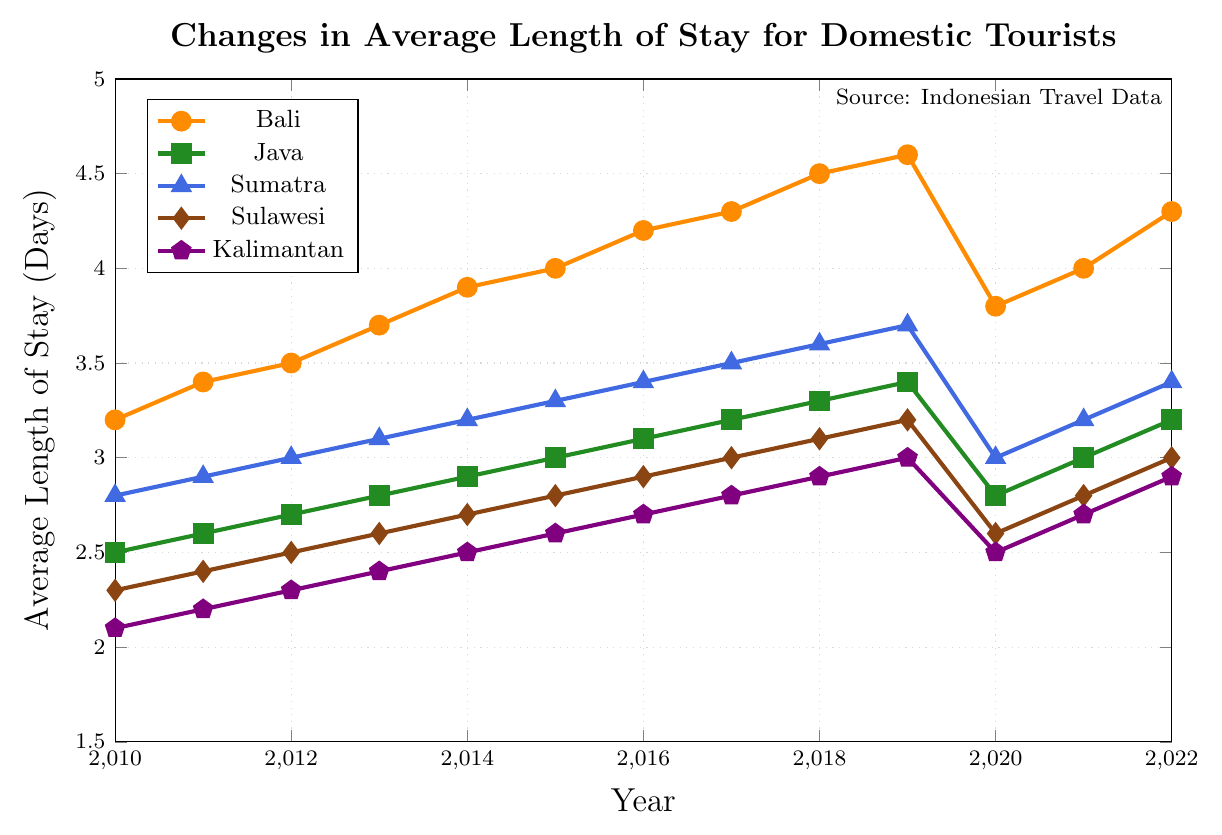What region had the longest average stay for domestic tourists in 2022? Observing the figure, the Bali line reaches the highest point in 2022, indicating the longest average stay for domestic tourists.
Answer: Bali How did the average length of stay in Bali change from 2019 to 2020? Comparing the points for Bali between 2019 and 2020, the average stay decreased from 4.6 to 3.8 days.
Answer: It decreased Which region experienced the biggest drop in the average length of stay in 2020 compared to 2019? Looking at the steepest drop between 2019 and 2020, all regions experienced a decline, but Bali had the most significant drop from 4.6 to 3.8.
Answer: Bali What is the trend of the average length of stay in Sulawesi from 2010 to 2022? Observing the Sulawesi line, it shows a general upward trend from 2.3 days in 2010 to 3.0 days in 2022, with a slight dip in 2020.
Answer: Upward Which region had a consistently lower average length of stay compared to Sumatra from 2010 to 2022? Comparing all lines with Sumatra's line, Kalimantan consistently shows lower average length of stay values than Sumatra throughout the years 2010 to 2022.
Answer: Kalimantan In which year did Java reach an average length of stay of 3.0 days for the first time? Tracing Java's line, it reaches the 3.0-day mark in 2015.
Answer: 2015 How much did the average length of stay in Kalimantan increase from 2010 to 2022? Kalimantan's average stay was 2.1 days in 2010 and increased to 2.9 days in 2022. The increase is 2.9 - 2.1 = 0.8 days.
Answer: 0.8 days Between 2011 and 2022, which region had the smallest increase in the average length of stay? By comparing the vertical distances between 2011 and 2022 points for all regions, Java shows the smallest increase from 2.6 to 3.2 days, i.e., 0.6 days.
Answer: Java What was the average length of stay for domestic tourists in Sumatra in 2015, and how did it compare to Bali's in the same year? Sumatra had an average stay of 3.3 days in 2015, while Bali had 4.0 days. Bali's is 0.7 days longer than Sumatra's.
Answer: 3.3 days; Bali's is longer by 0.7 days What is the average length of stay across all regions in 2022? Calculating the average for 2022: (4.3 + 3.2 + 3.4 + 3.0 + 2.9)/5 = 3.36 days.
Answer: 3.36 days 